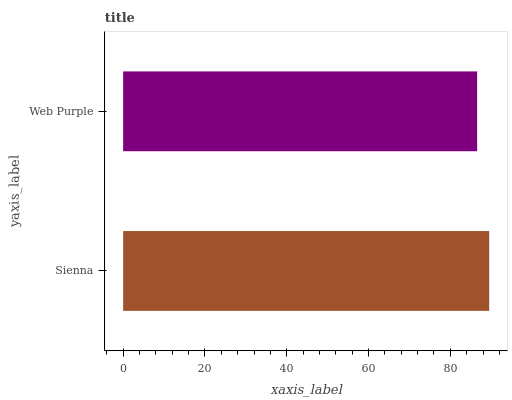Is Web Purple the minimum?
Answer yes or no. Yes. Is Sienna the maximum?
Answer yes or no. Yes. Is Web Purple the maximum?
Answer yes or no. No. Is Sienna greater than Web Purple?
Answer yes or no. Yes. Is Web Purple less than Sienna?
Answer yes or no. Yes. Is Web Purple greater than Sienna?
Answer yes or no. No. Is Sienna less than Web Purple?
Answer yes or no. No. Is Sienna the high median?
Answer yes or no. Yes. Is Web Purple the low median?
Answer yes or no. Yes. Is Web Purple the high median?
Answer yes or no. No. Is Sienna the low median?
Answer yes or no. No. 